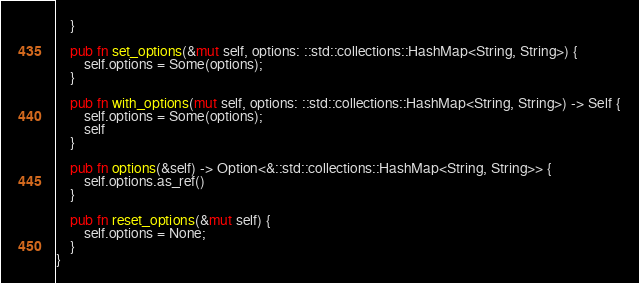<code> <loc_0><loc_0><loc_500><loc_500><_Rust_>    }

    pub fn set_options(&mut self, options: ::std::collections::HashMap<String, String>) {
        self.options = Some(options);
    }

    pub fn with_options(mut self, options: ::std::collections::HashMap<String, String>) -> Self {
        self.options = Some(options);
        self
    }

    pub fn options(&self) -> Option<&::std::collections::HashMap<String, String>> {
        self.options.as_ref()
    }

    pub fn reset_options(&mut self) {
        self.options = None;
    }
}
</code> 